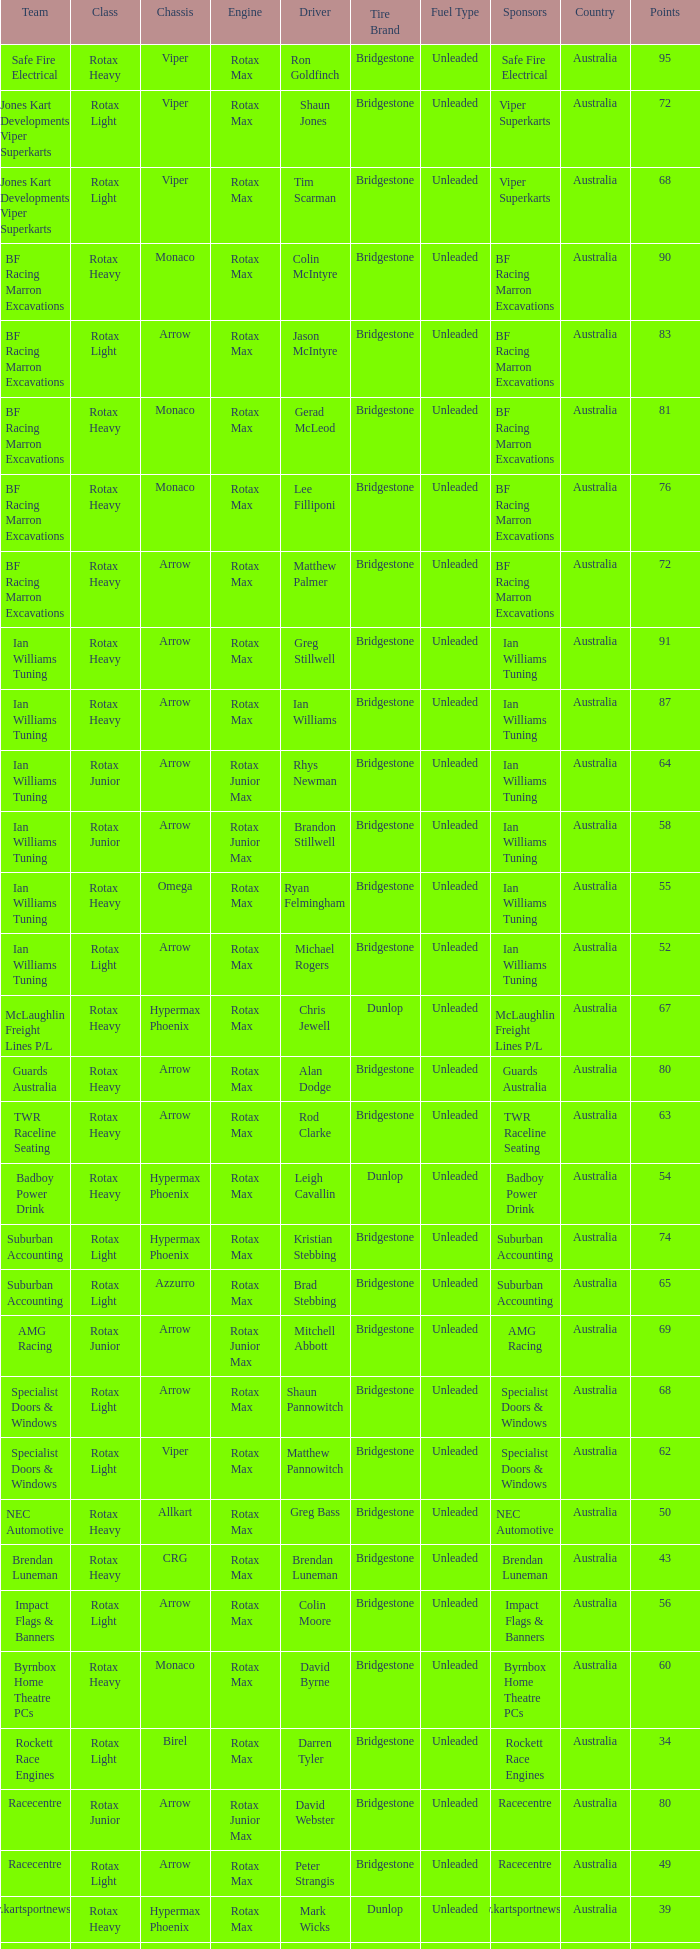What type of engine does the BF Racing Marron Excavations have that also has Monaco as chassis and Lee Filliponi as the driver? Rotax Max. 